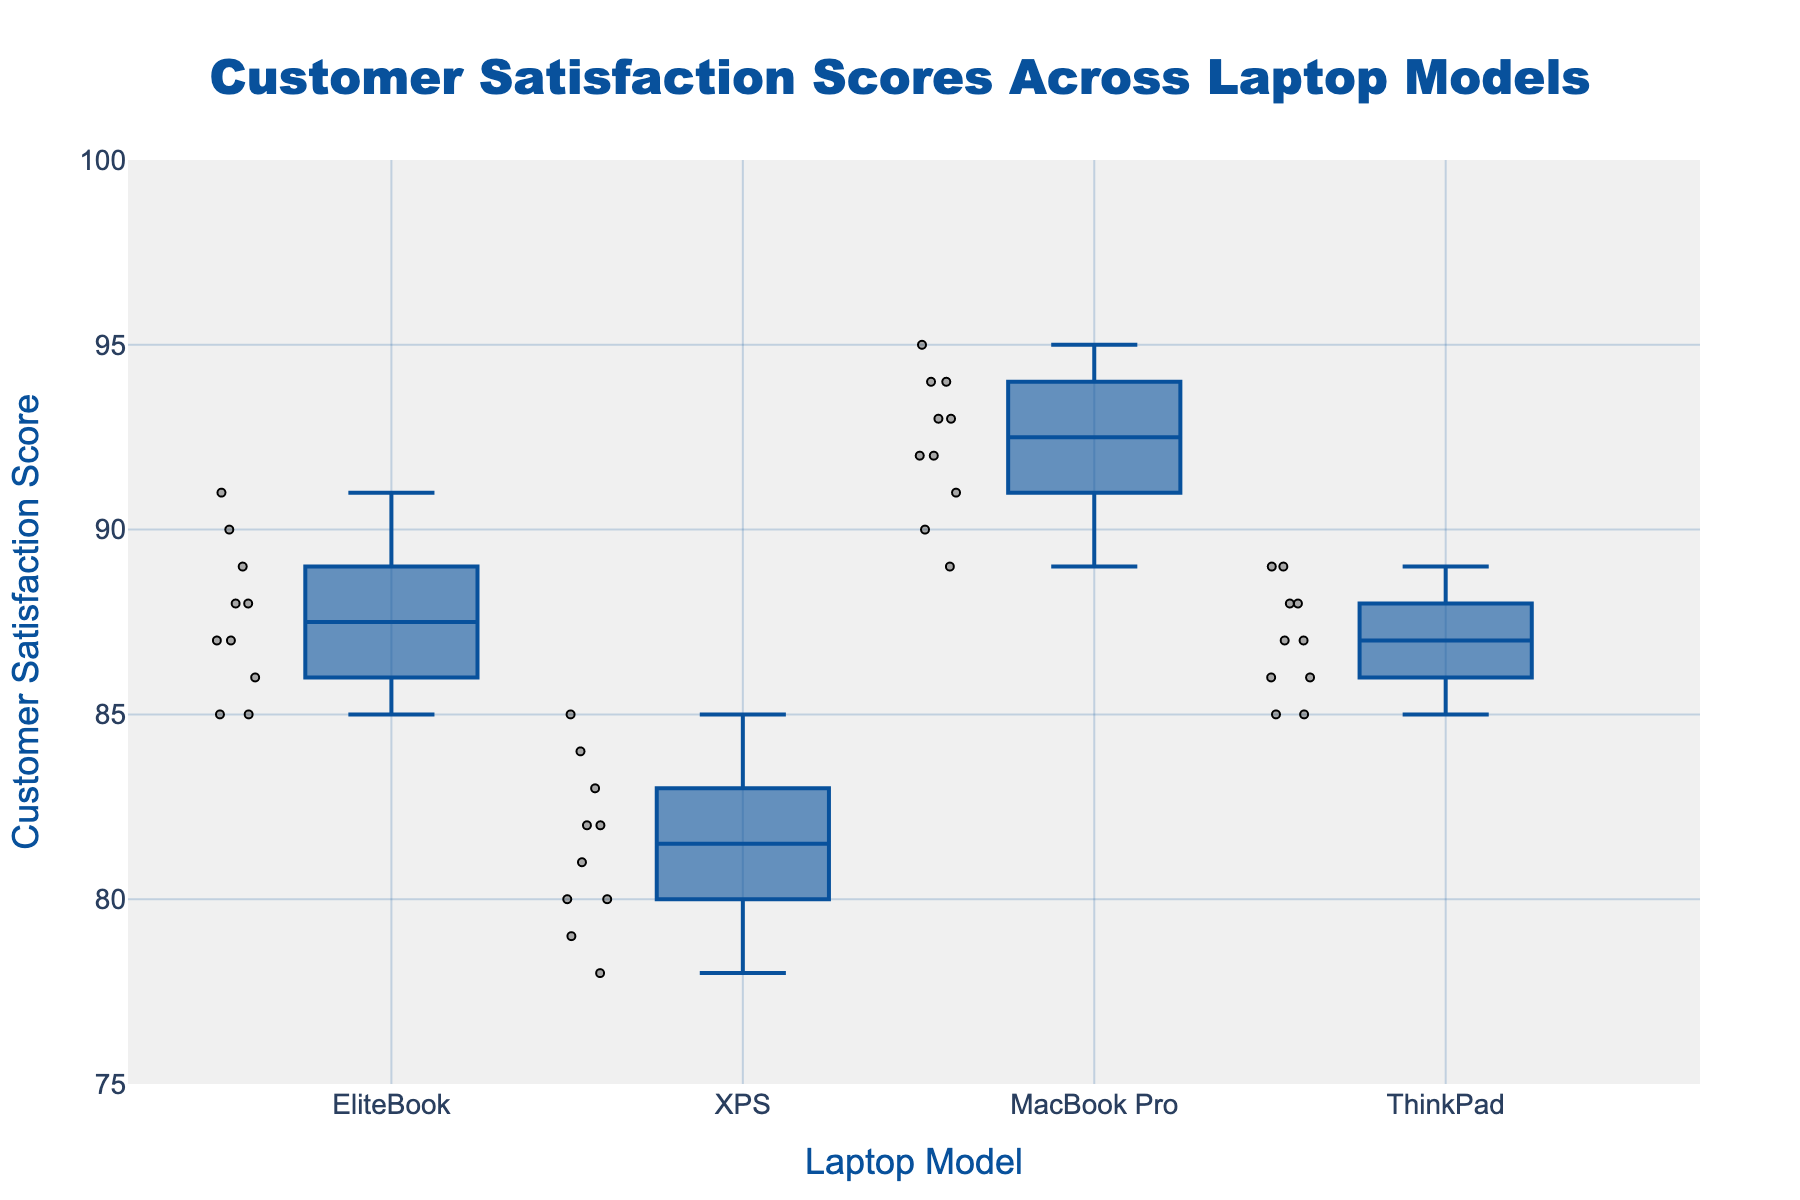What is the title of the figure? The title of the figure is prominently displayed at the top center. It summarizes the content of the plot.
Answer: Customer Satisfaction Scores Across Laptop Models Which laptop model has the highest median customer satisfaction score? From the box plot, it is clear that the MacBook Pro's median line within the box is at a higher position than those of the other models.
Answer: MacBook Pro What is the range of the customer satisfaction scores for the ThinkPad? The range in a box plot is the difference between the highest and lowest points. For the ThinkPad, the highest score is 89, and the lowest is 85, so the range is 89 - 85 = 4.
Answer: 4 Which model shows the most variation in customer satisfaction scores? Variation can be assessed by the interquartile range (IQR), which is the height of the box. EliteBook has a visibly taller box, indicating more variability.
Answer: EliteBook What is the lowest customer satisfaction score for the XPS? The lowest score for the XPS is represented by the bottom whisker of the box plot. For the XPS, this value is at 78.
Answer: 78 Which laptop model has the most consistent customer satisfaction scores? Consistency can be inferred from the shortest IQR (box height). The MacBook Pro and ThinkPad have shorter boxes compared to EliteBook and XPS, with MacBook Pro having nearly identical scores indicated by its smaller IQR.
Answer: MacBook Pro What is the median customer satisfaction score for the EliteBook? The median is represented by the line inside the box. For the EliteBook model, this value is around 88.
Answer: 88 Does any laptop model have any outliers in their customer satisfaction scores? Outliers would be represented by points outside the whiskers, but in this figure, none of the models have points outside their whiskers.
Answer: No Compare the interquartile range (IQR) of MacBook Pro and ThinkPad. Which has a larger IQR and by how much? IQR is the distance between the 1st quartile and the 3rd quartile (top and bottom of the box). For MacBook Pro, IQR ranges from 91 to 94, thus IQR = 94 - 91 = 3. For ThinkPad, IQR ranges from 86 to 88, IQR = 88 - 86 = 2. The MacBook Pro's IQR is 1 unit larger.
Answer: MacBook Pro by 1 